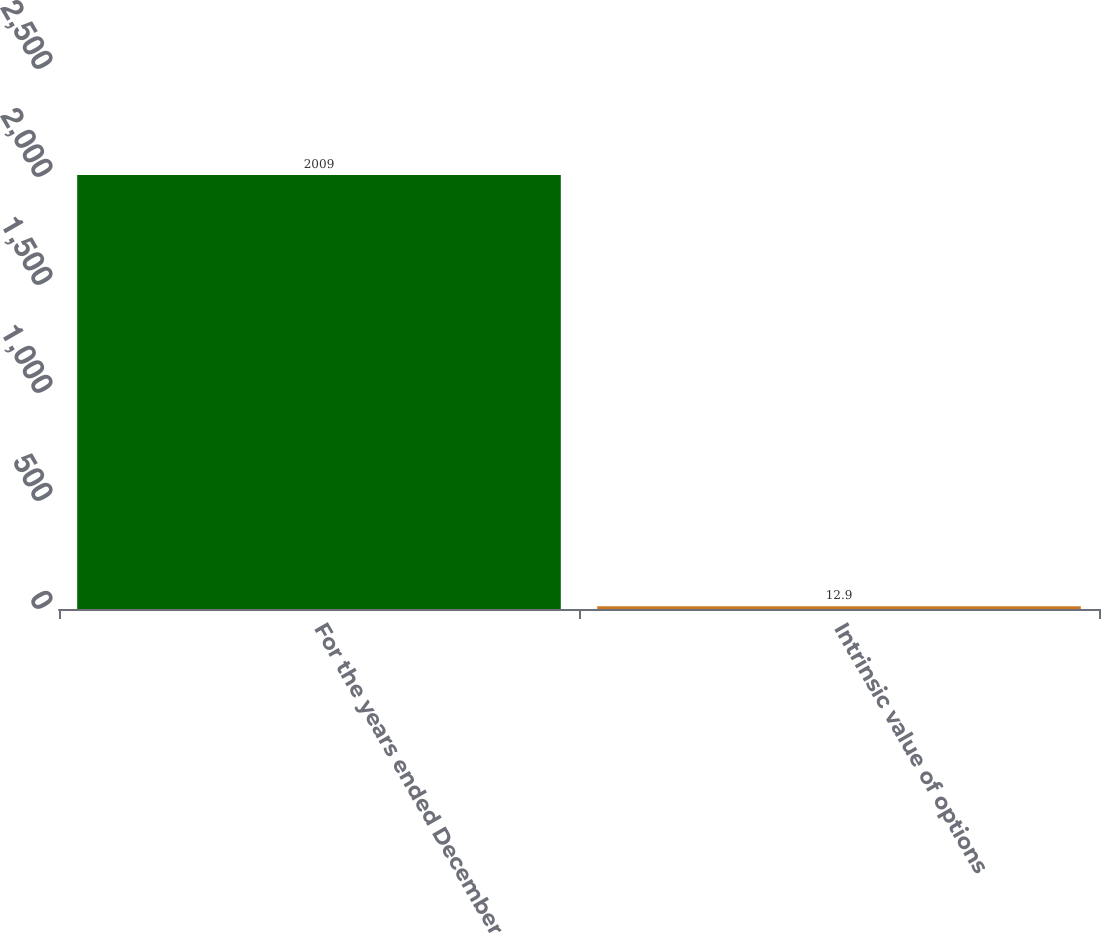Convert chart. <chart><loc_0><loc_0><loc_500><loc_500><bar_chart><fcel>For the years ended December<fcel>Intrinsic value of options<nl><fcel>2009<fcel>12.9<nl></chart> 